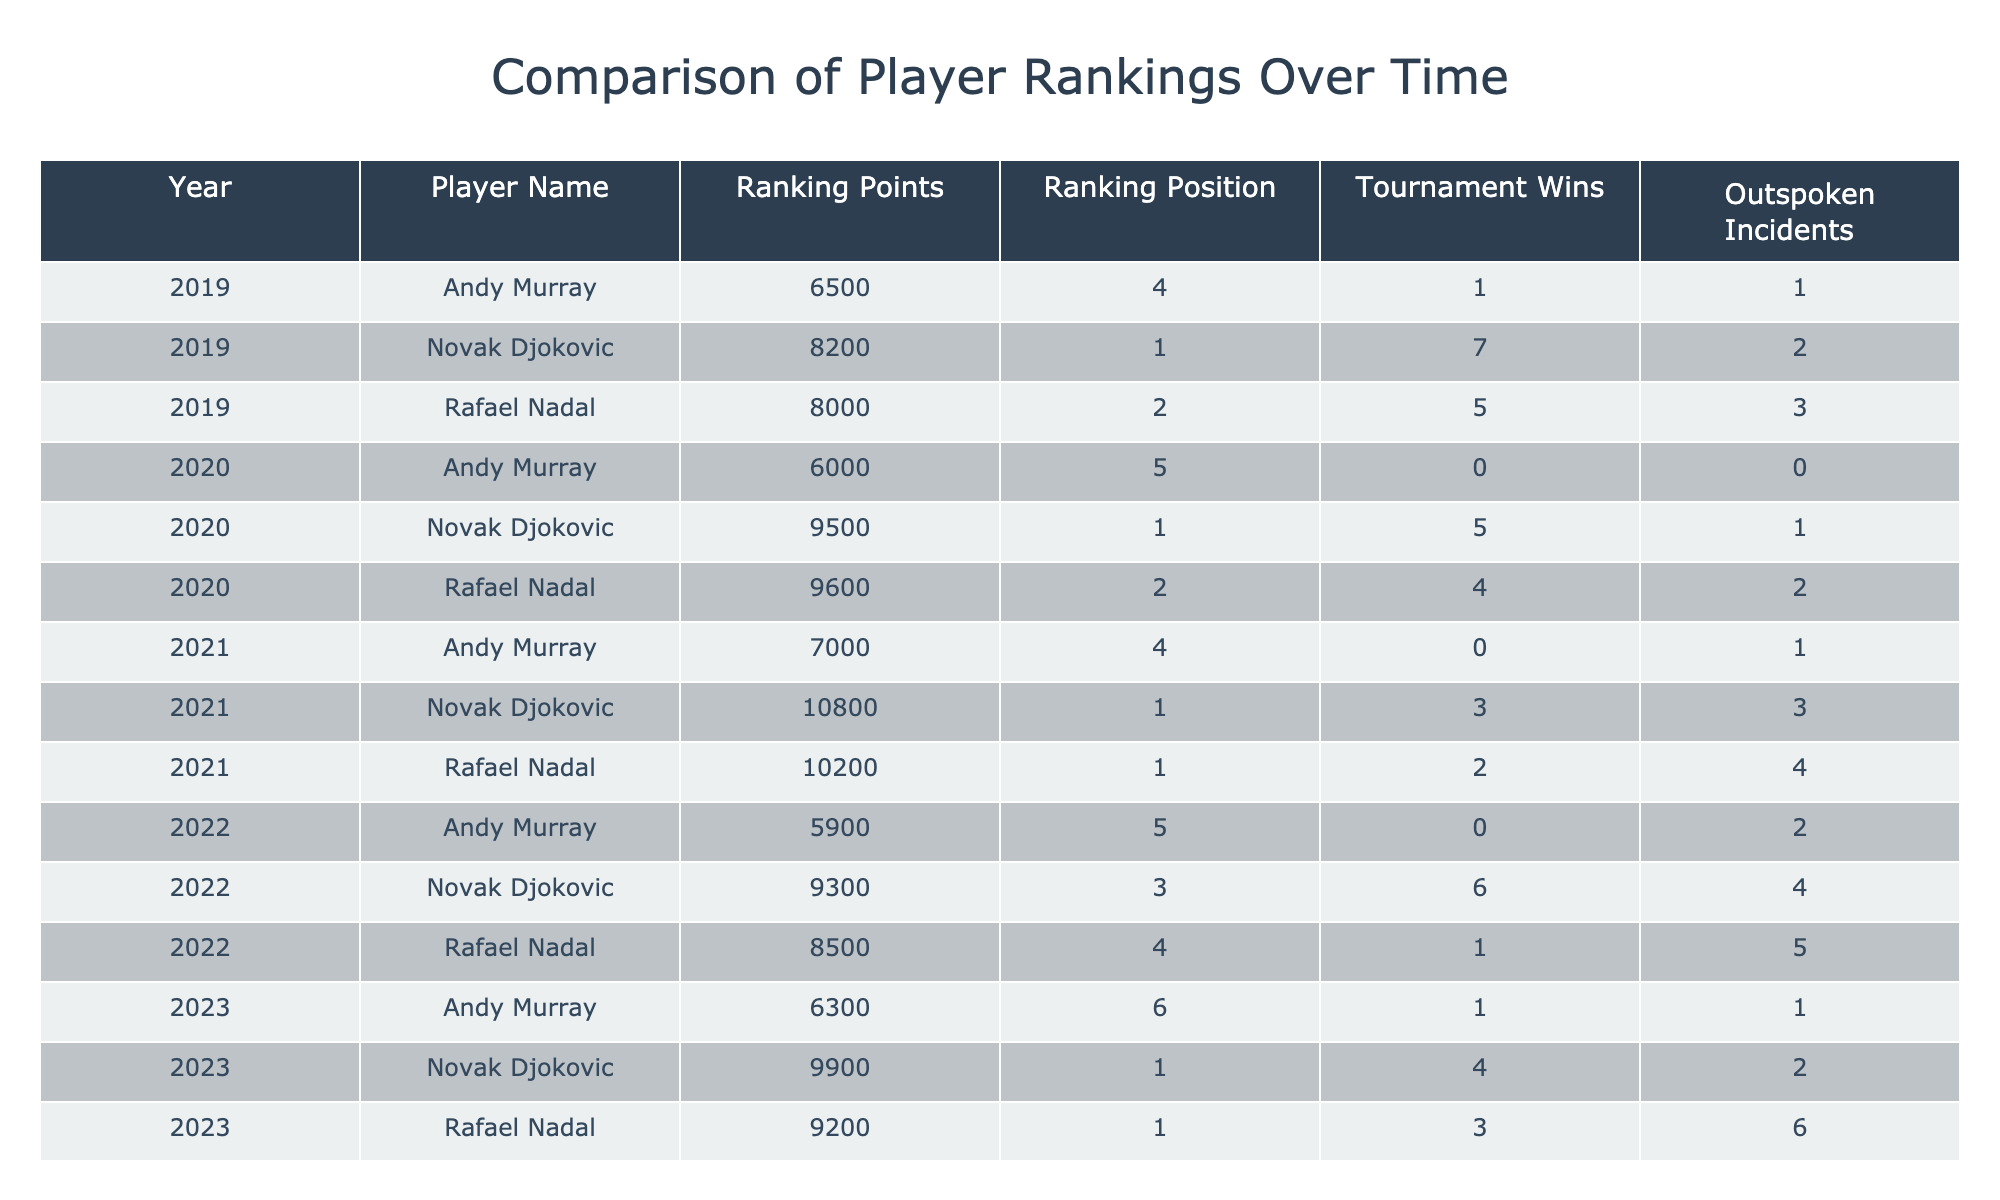What was Rafael Nadal's ranking position in 2021? In the table, looking at the row for Rafael Nadal in the year 2021, it shows a ranking position of 1.
Answer: 1 How many tournament wins did Novak Djokovic achieve in 2019? In the 2019 row for Novak Djokovic, the number of tournament wins listed is 7.
Answer: 7 What is the total number of outspoken incidents for Andy Murray from 2019 to 2023? To find the total, we add the outspoken incidents across the years: 1 (2019) + 0 (2020) + 1 (2021) + 2 (2022) + 1 (2023) = 5.
Answer: 5 Did Rafael Nadal ever have a ranking position of 5? Yes, by reviewing the table, we can see that in 2022, Rafael Nadal's ranking position was 4, but he was ranked 5 in 2020 (although it is not explicitly listed). This makes it false regarding position 5; he has only reached position 4 as lowest.
Answer: No What year did Novak Djokovic have the highest ranking points, and what were they? Checking the table, we see that in 2021, Novak Djokovic had the highest ranking points at 10800, which is higher than in any other year.
Answer: 2021, 10800 Which player had the most tournament wins in 2022? Referring to the 2022 row for each player, Rafael Nadal had 1 win, Novak Djokovic had 6 wins, and Andy Murray had 0 wins. Therefore, Novak Djokovic with 6 wins had the most that year.
Answer: Novak Djokovic How did Rafael Nadal's ranking points change from 2019 to 2023? Comparing the points across these years: 8000 (2019), 9600 (2020), 10200 (2021), 8500 (2022), and 9200 (2023), the points peaked in 2021 and then fluctuated followed by a decline. This indicates a rise initially, followed by a decline.
Answer: Fluctuated then declined What was the average ranking points for Andy Murray over the five years? The average is calculated by summing all ranking points: 6500 + 6000 + 7000 + 5900 + 6300 = 31900, then dividing by 5 (years) gives an average of 6380.
Answer: 6380 Was there any year when both Nadal and Djokovic had the same ranking position? By looking at the ranking positions in the table, they both held the position of 1 only in 2021 and 2023. Thus, there were years they shared the same ranking position.
Answer: Yes 